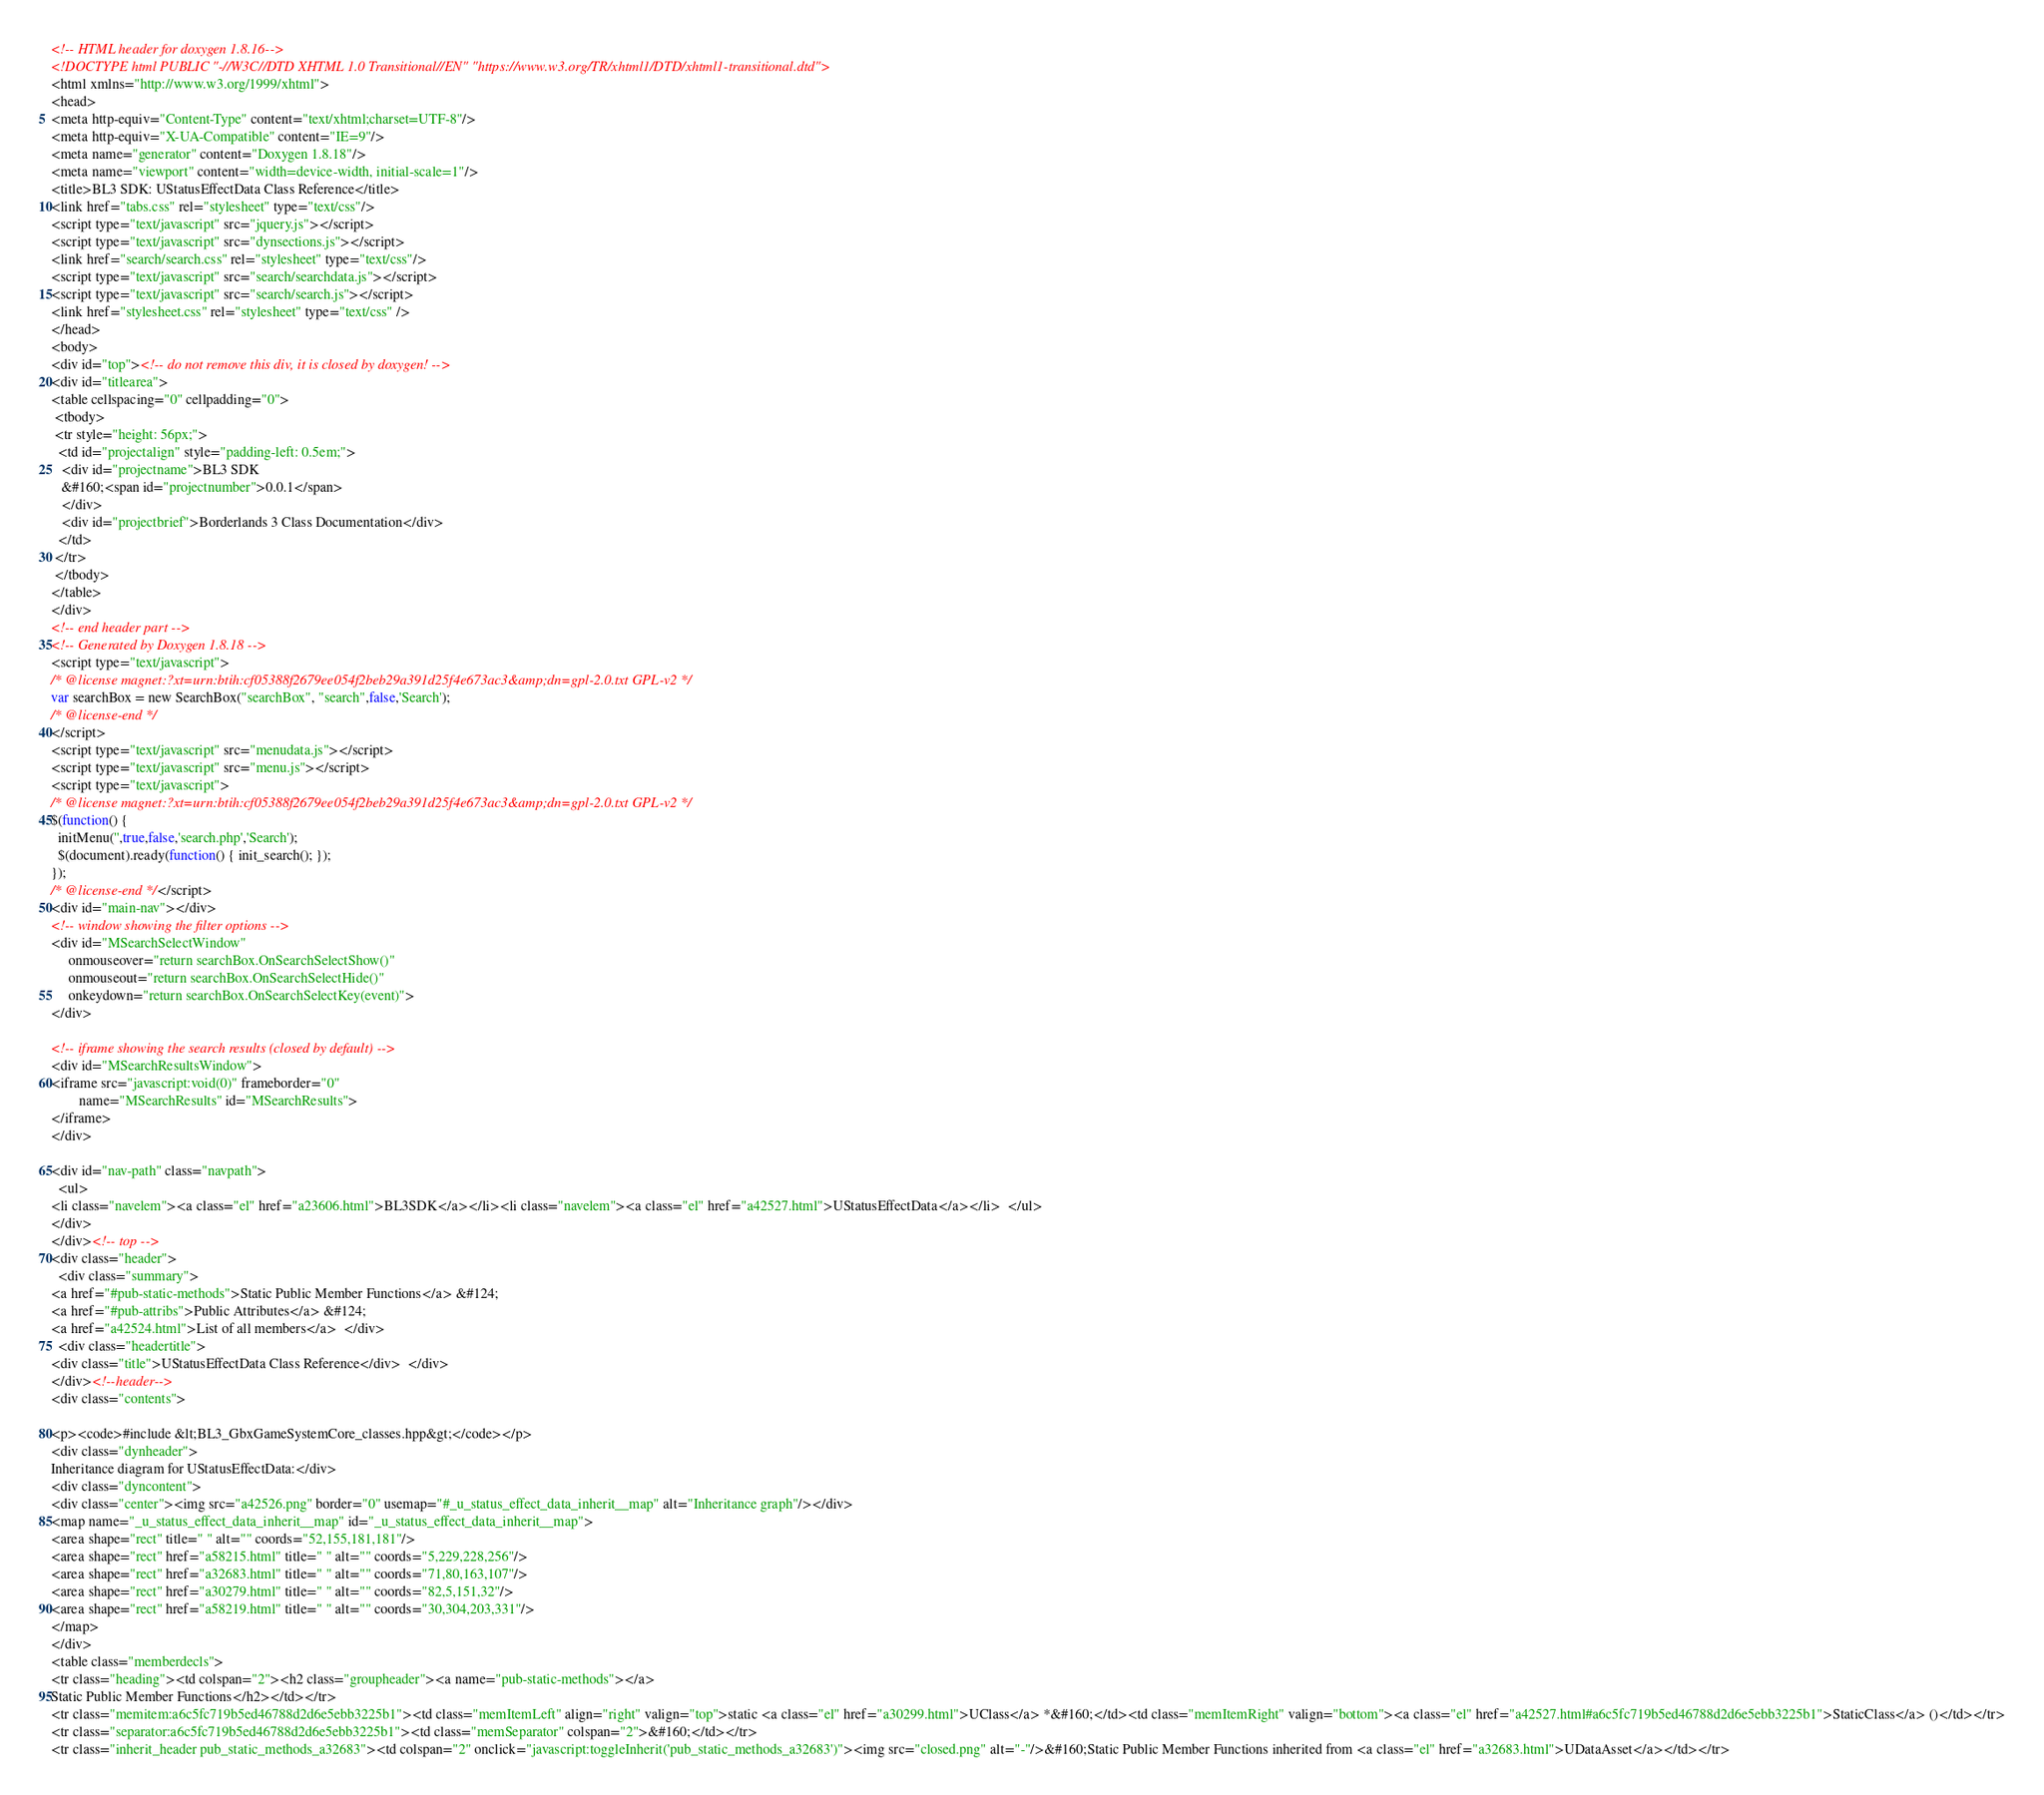Convert code to text. <code><loc_0><loc_0><loc_500><loc_500><_HTML_><!-- HTML header for doxygen 1.8.16-->
<!DOCTYPE html PUBLIC "-//W3C//DTD XHTML 1.0 Transitional//EN" "https://www.w3.org/TR/xhtml1/DTD/xhtml1-transitional.dtd">
<html xmlns="http://www.w3.org/1999/xhtml">
<head>
<meta http-equiv="Content-Type" content="text/xhtml;charset=UTF-8"/>
<meta http-equiv="X-UA-Compatible" content="IE=9"/>
<meta name="generator" content="Doxygen 1.8.18"/>
<meta name="viewport" content="width=device-width, initial-scale=1"/>
<title>BL3 SDK: UStatusEffectData Class Reference</title>
<link href="tabs.css" rel="stylesheet" type="text/css"/>
<script type="text/javascript" src="jquery.js"></script>
<script type="text/javascript" src="dynsections.js"></script>
<link href="search/search.css" rel="stylesheet" type="text/css"/>
<script type="text/javascript" src="search/searchdata.js"></script>
<script type="text/javascript" src="search/search.js"></script>
<link href="stylesheet.css" rel="stylesheet" type="text/css" />
</head>
<body>
<div id="top"><!-- do not remove this div, it is closed by doxygen! -->
<div id="titlearea">
<table cellspacing="0" cellpadding="0">
 <tbody>
 <tr style="height: 56px;">
  <td id="projectalign" style="padding-left: 0.5em;">
   <div id="projectname">BL3 SDK
   &#160;<span id="projectnumber">0.0.1</span>
   </div>
   <div id="projectbrief">Borderlands 3 Class Documentation</div>
  </td>
 </tr>
 </tbody>
</table>
</div>
<!-- end header part -->
<!-- Generated by Doxygen 1.8.18 -->
<script type="text/javascript">
/* @license magnet:?xt=urn:btih:cf05388f2679ee054f2beb29a391d25f4e673ac3&amp;dn=gpl-2.0.txt GPL-v2 */
var searchBox = new SearchBox("searchBox", "search",false,'Search');
/* @license-end */
</script>
<script type="text/javascript" src="menudata.js"></script>
<script type="text/javascript" src="menu.js"></script>
<script type="text/javascript">
/* @license magnet:?xt=urn:btih:cf05388f2679ee054f2beb29a391d25f4e673ac3&amp;dn=gpl-2.0.txt GPL-v2 */
$(function() {
  initMenu('',true,false,'search.php','Search');
  $(document).ready(function() { init_search(); });
});
/* @license-end */</script>
<div id="main-nav"></div>
<!-- window showing the filter options -->
<div id="MSearchSelectWindow"
     onmouseover="return searchBox.OnSearchSelectShow()"
     onmouseout="return searchBox.OnSearchSelectHide()"
     onkeydown="return searchBox.OnSearchSelectKey(event)">
</div>

<!-- iframe showing the search results (closed by default) -->
<div id="MSearchResultsWindow">
<iframe src="javascript:void(0)" frameborder="0" 
        name="MSearchResults" id="MSearchResults">
</iframe>
</div>

<div id="nav-path" class="navpath">
  <ul>
<li class="navelem"><a class="el" href="a23606.html">BL3SDK</a></li><li class="navelem"><a class="el" href="a42527.html">UStatusEffectData</a></li>  </ul>
</div>
</div><!-- top -->
<div class="header">
  <div class="summary">
<a href="#pub-static-methods">Static Public Member Functions</a> &#124;
<a href="#pub-attribs">Public Attributes</a> &#124;
<a href="a42524.html">List of all members</a>  </div>
  <div class="headertitle">
<div class="title">UStatusEffectData Class Reference</div>  </div>
</div><!--header-->
<div class="contents">

<p><code>#include &lt;BL3_GbxGameSystemCore_classes.hpp&gt;</code></p>
<div class="dynheader">
Inheritance diagram for UStatusEffectData:</div>
<div class="dyncontent">
<div class="center"><img src="a42526.png" border="0" usemap="#_u_status_effect_data_inherit__map" alt="Inheritance graph"/></div>
<map name="_u_status_effect_data_inherit__map" id="_u_status_effect_data_inherit__map">
<area shape="rect" title=" " alt="" coords="52,155,181,181"/>
<area shape="rect" href="a58215.html" title=" " alt="" coords="5,229,228,256"/>
<area shape="rect" href="a32683.html" title=" " alt="" coords="71,80,163,107"/>
<area shape="rect" href="a30279.html" title=" " alt="" coords="82,5,151,32"/>
<area shape="rect" href="a58219.html" title=" " alt="" coords="30,304,203,331"/>
</map>
</div>
<table class="memberdecls">
<tr class="heading"><td colspan="2"><h2 class="groupheader"><a name="pub-static-methods"></a>
Static Public Member Functions</h2></td></tr>
<tr class="memitem:a6c5fc719b5ed46788d2d6e5ebb3225b1"><td class="memItemLeft" align="right" valign="top">static <a class="el" href="a30299.html">UClass</a> *&#160;</td><td class="memItemRight" valign="bottom"><a class="el" href="a42527.html#a6c5fc719b5ed46788d2d6e5ebb3225b1">StaticClass</a> ()</td></tr>
<tr class="separator:a6c5fc719b5ed46788d2d6e5ebb3225b1"><td class="memSeparator" colspan="2">&#160;</td></tr>
<tr class="inherit_header pub_static_methods_a32683"><td colspan="2" onclick="javascript:toggleInherit('pub_static_methods_a32683')"><img src="closed.png" alt="-"/>&#160;Static Public Member Functions inherited from <a class="el" href="a32683.html">UDataAsset</a></td></tr></code> 